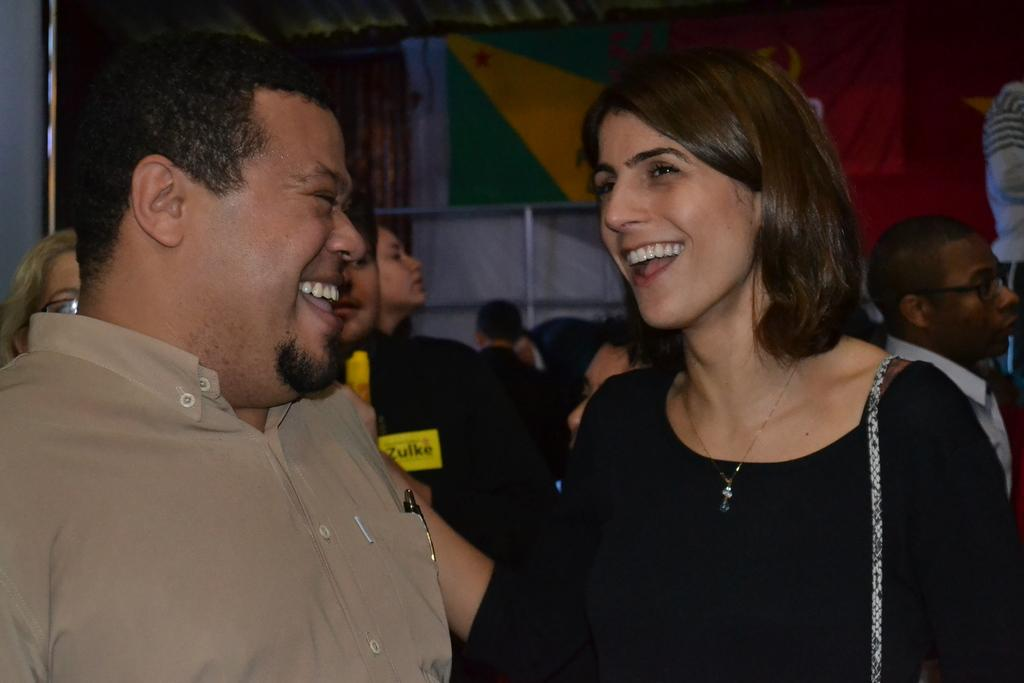How many people are smiling in the image? There are two persons smiling in the image. Can you describe the group of people in the image? There is a group of people standing in the image. What can be seen in the background of the image? There are flags in the background of the image. What is the wealth of the dirt visible in the image? There is no dirt visible in the image, so it is not possible to determine its wealth. 